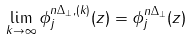<formula> <loc_0><loc_0><loc_500><loc_500>\lim _ { k \rightarrow \infty } \phi _ { j } ^ { n \Delta _ { \perp } , ( k ) } ( z ) = \phi _ { j } ^ { n \Delta _ { \perp } } ( z )</formula> 